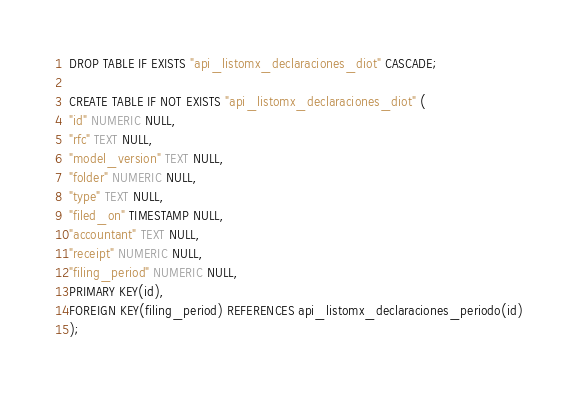<code> <loc_0><loc_0><loc_500><loc_500><_SQL_>DROP TABLE IF EXISTS "api_listomx_declaraciones_diot" CASCADE;

CREATE TABLE IF NOT EXISTS "api_listomx_declaraciones_diot" (
"id" NUMERIC NULL,
"rfc" TEXT NULL,
"model_version" TEXT NULL,
"folder" NUMERIC NULL,
"type" TEXT NULL,
"filed_on" TIMESTAMP NULL,
"accountant" TEXT NULL,
"receipt" NUMERIC NULL,
"filing_period" NUMERIC NULL,
PRIMARY KEY(id),
FOREIGN KEY(filing_period) REFERENCES api_listomx_declaraciones_periodo(id)
);
</code> 